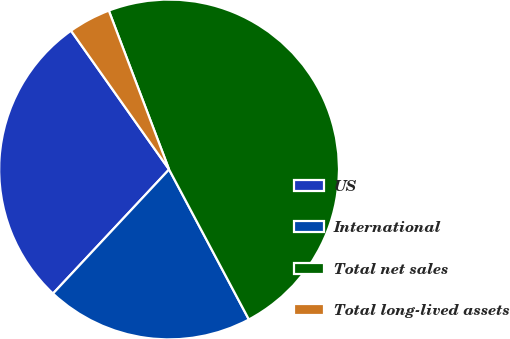<chart> <loc_0><loc_0><loc_500><loc_500><pie_chart><fcel>US<fcel>International<fcel>Total net sales<fcel>Total long-lived assets<nl><fcel>28.24%<fcel>19.75%<fcel>47.99%<fcel>4.02%<nl></chart> 